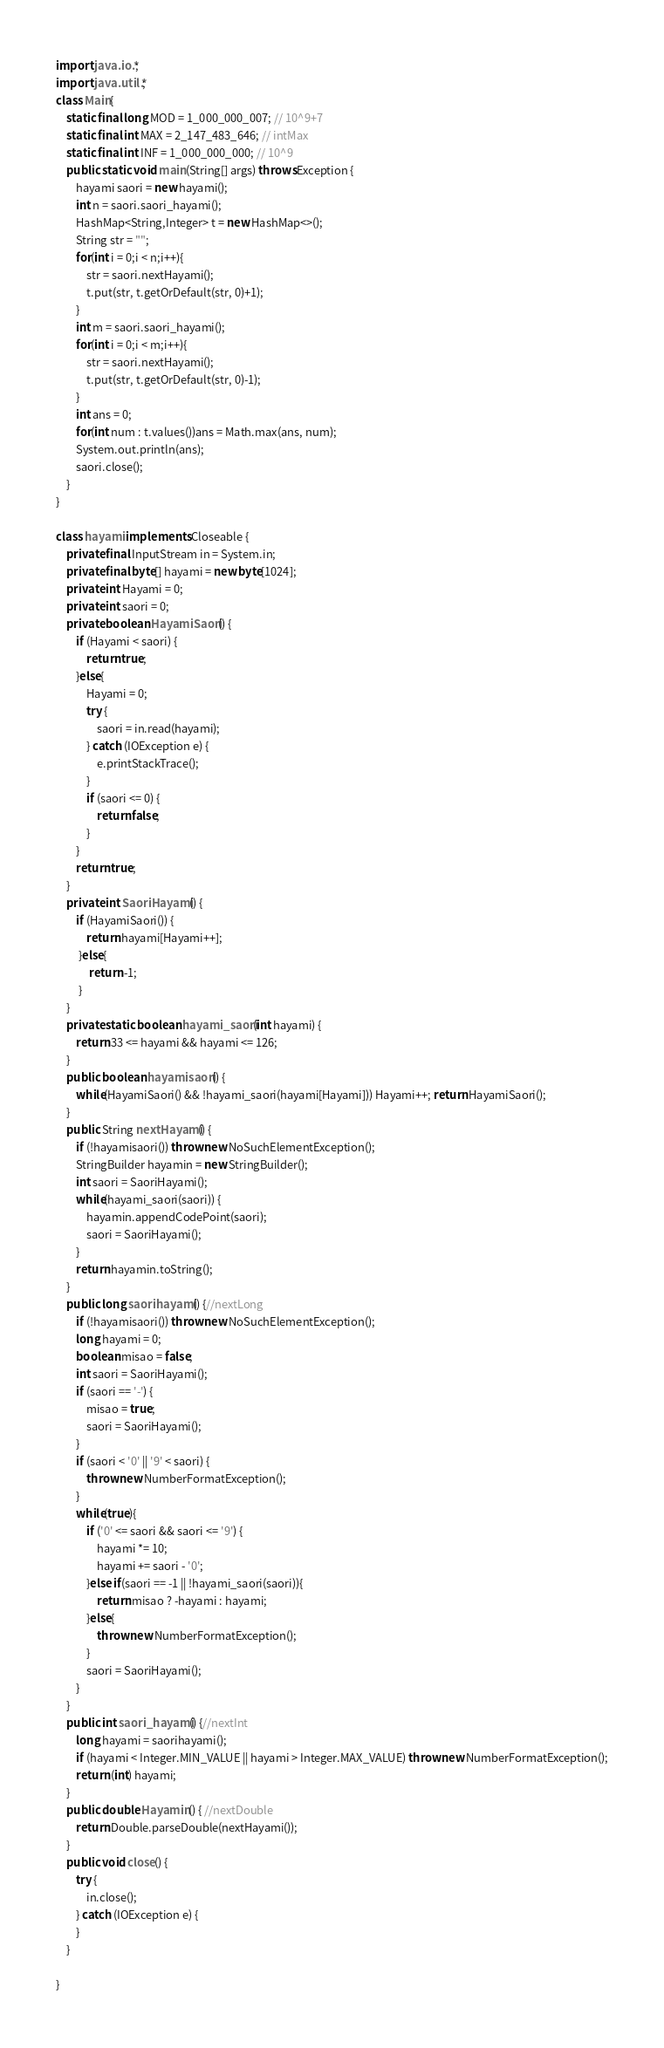Convert code to text. <code><loc_0><loc_0><loc_500><loc_500><_Java_>import java.io.*;
import java.util.*;
class Main{
	static final long MOD = 1_000_000_007; // 10^9+7
    static final int MAX = 2_147_483_646; // intMax 
    static final int INF = 1_000_000_000; // 10^9  
    public static void main(String[] args) throws Exception {
		hayami saori = new hayami();
		int n = saori.saori_hayami();
		HashMap<String,Integer> t = new HashMap<>();
		String str = "";
		for(int i = 0;i < n;i++){
			str = saori.nextHayami();
			t.put(str, t.getOrDefault(str, 0)+1);
		}
		int m = saori.saori_hayami();
		for(int i = 0;i < m;i++){
			str = saori.nextHayami();
			t.put(str, t.getOrDefault(str, 0)-1);
		}
		int ans = 0;
		for(int num : t.values())ans = Math.max(ans, num);
		System.out.println(ans);
		saori.close();
    }
}

class hayami implements Closeable {
	private final InputStream in = System.in;
	private final byte[] hayami = new byte[1024];
	private int Hayami = 0;
	private int saori = 0;
	private boolean HayamiSaori() {
		if (Hayami < saori) {
			return true;
		}else{
			Hayami = 0;
			try {
				saori = in.read(hayami);
			} catch (IOException e) {
				e.printStackTrace();
			}
			if (saori <= 0) {
				return false;
			}
		}
		return true;
	}
	private int SaoriHayami() { 
		if (HayamiSaori()) {
            return hayami[Hayami++];
         }else{
             return -1;
         }
	}
	private static boolean hayami_saori(int hayami) { 
		return 33 <= hayami && hayami <= 126;
	}
	public boolean hayamisaori() { 
		while(HayamiSaori() && !hayami_saori(hayami[Hayami])) Hayami++; return HayamiSaori();
	}
	public String nextHayami() {
		if (!hayamisaori()) throw new NoSuchElementException();
		StringBuilder hayamin = new StringBuilder();
		int saori = SaoriHayami();
		while(hayami_saori(saori)) {
			hayamin.appendCodePoint(saori);
			saori = SaoriHayami();
		}
		return hayamin.toString();
	}
	public long saorihayami() {//nextLong
		if (!hayamisaori()) throw new NoSuchElementException();
		long hayami = 0;
		boolean misao = false;
		int saori = SaoriHayami();
		if (saori == '-') {
			misao = true;
			saori = SaoriHayami();
		}
		if (saori < '0' || '9' < saori) {
			throw new NumberFormatException();
		}
		while(true){
			if ('0' <= saori && saori <= '9') {
				hayami *= 10;
				hayami += saori - '0';
			}else if(saori == -1 || !hayami_saori(saori)){
				return misao ? -hayami : hayami;
			}else{
				throw new NumberFormatException();
			}
			saori = SaoriHayami();
		}
	}
	public int saori_hayami() {//nextInt
		long hayami = saorihayami();
		if (hayami < Integer.MIN_VALUE || hayami > Integer.MAX_VALUE) throw new NumberFormatException();
		return (int) hayami;
	}
	public double Hayamin() { //nextDouble
		return Double.parseDouble(nextHayami());
	}
	public void close() {
		try {
			in.close();
		} catch (IOException e) {
		}
    }
    
}</code> 